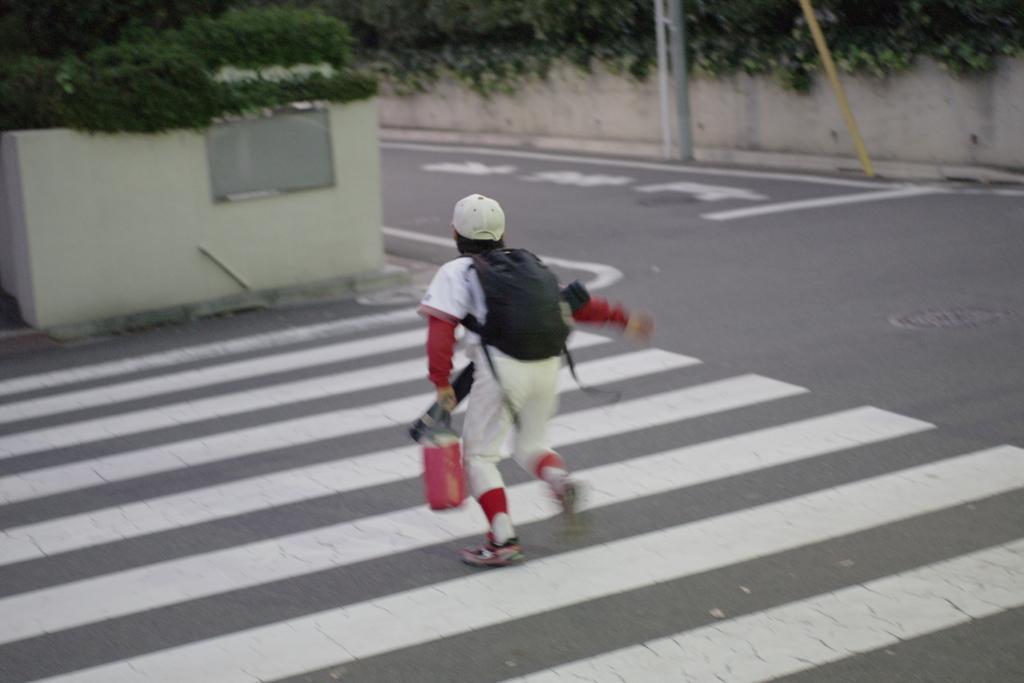In one or two sentences, can you explain what this image depicts? In the center of the picture there is a kid running on the road. In the background there are plants, wall, road and poles. 